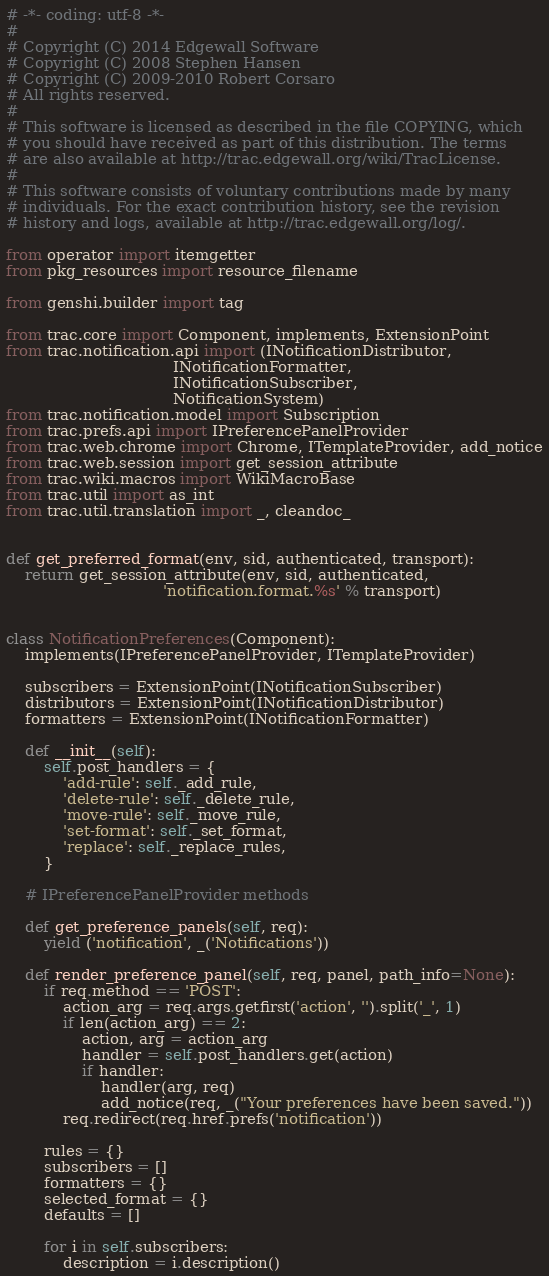<code> <loc_0><loc_0><loc_500><loc_500><_Python_># -*- coding: utf-8 -*-
#
# Copyright (C) 2014 Edgewall Software
# Copyright (C) 2008 Stephen Hansen
# Copyright (C) 2009-2010 Robert Corsaro
# All rights reserved.
#
# This software is licensed as described in the file COPYING, which
# you should have received as part of this distribution. The terms
# are also available at http://trac.edgewall.org/wiki/TracLicense.
#
# This software consists of voluntary contributions made by many
# individuals. For the exact contribution history, see the revision
# history and logs, available at http://trac.edgewall.org/log/.

from operator import itemgetter
from pkg_resources import resource_filename

from genshi.builder import tag

from trac.core import Component, implements, ExtensionPoint
from trac.notification.api import (INotificationDistributor,
                                   INotificationFormatter,
                                   INotificationSubscriber,
                                   NotificationSystem)
from trac.notification.model import Subscription
from trac.prefs.api import IPreferencePanelProvider
from trac.web.chrome import Chrome, ITemplateProvider, add_notice
from trac.web.session import get_session_attribute
from trac.wiki.macros import WikiMacroBase
from trac.util import as_int
from trac.util.translation import _, cleandoc_


def get_preferred_format(env, sid, authenticated, transport):
    return get_session_attribute(env, sid, authenticated,
                                 'notification.format.%s' % transport)


class NotificationPreferences(Component):
    implements(IPreferencePanelProvider, ITemplateProvider)

    subscribers = ExtensionPoint(INotificationSubscriber)
    distributors = ExtensionPoint(INotificationDistributor)
    formatters = ExtensionPoint(INotificationFormatter)

    def __init__(self):
        self.post_handlers = {
            'add-rule': self._add_rule,
            'delete-rule': self._delete_rule,
            'move-rule': self._move_rule,
            'set-format': self._set_format,
            'replace': self._replace_rules,
        }

    # IPreferencePanelProvider methods

    def get_preference_panels(self, req):
        yield ('notification', _('Notifications'))

    def render_preference_panel(self, req, panel, path_info=None):
        if req.method == 'POST':
            action_arg = req.args.getfirst('action', '').split('_', 1)
            if len(action_arg) == 2:
                action, arg = action_arg
                handler = self.post_handlers.get(action)
                if handler:
                    handler(arg, req)
                    add_notice(req, _("Your preferences have been saved."))
            req.redirect(req.href.prefs('notification'))

        rules = {}
        subscribers = []
        formatters = {}
        selected_format = {}
        defaults = []

        for i in self.subscribers:
            description = i.description()</code> 